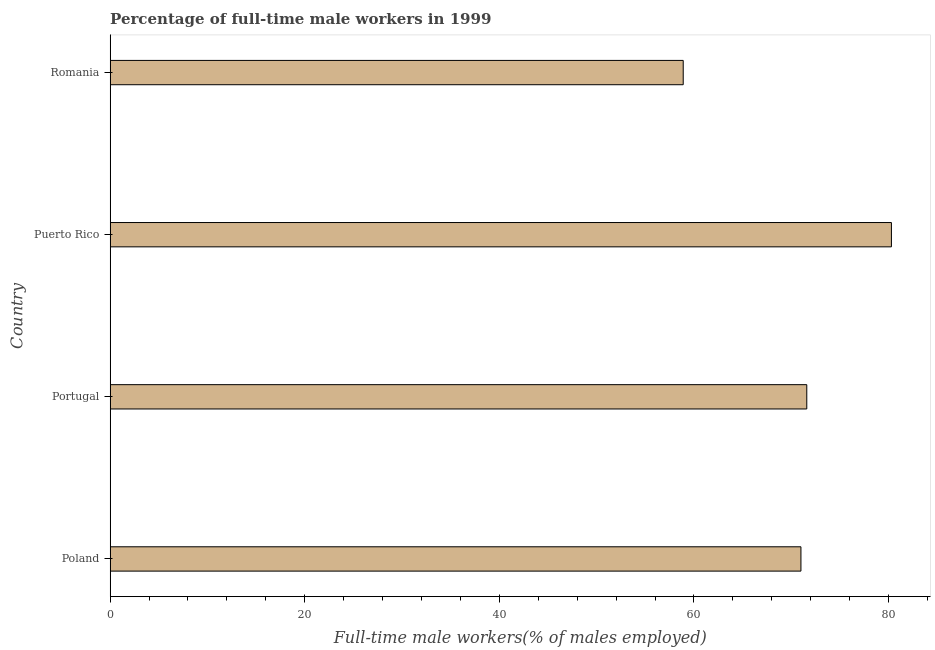Does the graph contain any zero values?
Make the answer very short. No. Does the graph contain grids?
Your response must be concise. No. What is the title of the graph?
Your answer should be very brief. Percentage of full-time male workers in 1999. What is the label or title of the X-axis?
Give a very brief answer. Full-time male workers(% of males employed). What is the label or title of the Y-axis?
Offer a terse response. Country. What is the percentage of full-time male workers in Puerto Rico?
Make the answer very short. 80.3. Across all countries, what is the maximum percentage of full-time male workers?
Make the answer very short. 80.3. Across all countries, what is the minimum percentage of full-time male workers?
Provide a succinct answer. 58.9. In which country was the percentage of full-time male workers maximum?
Offer a very short reply. Puerto Rico. In which country was the percentage of full-time male workers minimum?
Offer a very short reply. Romania. What is the sum of the percentage of full-time male workers?
Offer a terse response. 281.8. What is the average percentage of full-time male workers per country?
Keep it short and to the point. 70.45. What is the median percentage of full-time male workers?
Your response must be concise. 71.3. What is the ratio of the percentage of full-time male workers in Poland to that in Romania?
Your response must be concise. 1.21. Is the difference between the percentage of full-time male workers in Portugal and Puerto Rico greater than the difference between any two countries?
Your response must be concise. No. What is the difference between the highest and the second highest percentage of full-time male workers?
Give a very brief answer. 8.7. Is the sum of the percentage of full-time male workers in Portugal and Romania greater than the maximum percentage of full-time male workers across all countries?
Your answer should be compact. Yes. What is the difference between the highest and the lowest percentage of full-time male workers?
Keep it short and to the point. 21.4. In how many countries, is the percentage of full-time male workers greater than the average percentage of full-time male workers taken over all countries?
Offer a very short reply. 3. Are all the bars in the graph horizontal?
Give a very brief answer. Yes. How many countries are there in the graph?
Your response must be concise. 4. What is the Full-time male workers(% of males employed) in Poland?
Offer a very short reply. 71. What is the Full-time male workers(% of males employed) of Portugal?
Ensure brevity in your answer.  71.6. What is the Full-time male workers(% of males employed) of Puerto Rico?
Give a very brief answer. 80.3. What is the Full-time male workers(% of males employed) of Romania?
Keep it short and to the point. 58.9. What is the difference between the Full-time male workers(% of males employed) in Poland and Portugal?
Offer a terse response. -0.6. What is the difference between the Full-time male workers(% of males employed) in Poland and Romania?
Keep it short and to the point. 12.1. What is the difference between the Full-time male workers(% of males employed) in Puerto Rico and Romania?
Provide a short and direct response. 21.4. What is the ratio of the Full-time male workers(% of males employed) in Poland to that in Portugal?
Make the answer very short. 0.99. What is the ratio of the Full-time male workers(% of males employed) in Poland to that in Puerto Rico?
Keep it short and to the point. 0.88. What is the ratio of the Full-time male workers(% of males employed) in Poland to that in Romania?
Provide a short and direct response. 1.21. What is the ratio of the Full-time male workers(% of males employed) in Portugal to that in Puerto Rico?
Provide a short and direct response. 0.89. What is the ratio of the Full-time male workers(% of males employed) in Portugal to that in Romania?
Keep it short and to the point. 1.22. What is the ratio of the Full-time male workers(% of males employed) in Puerto Rico to that in Romania?
Your response must be concise. 1.36. 